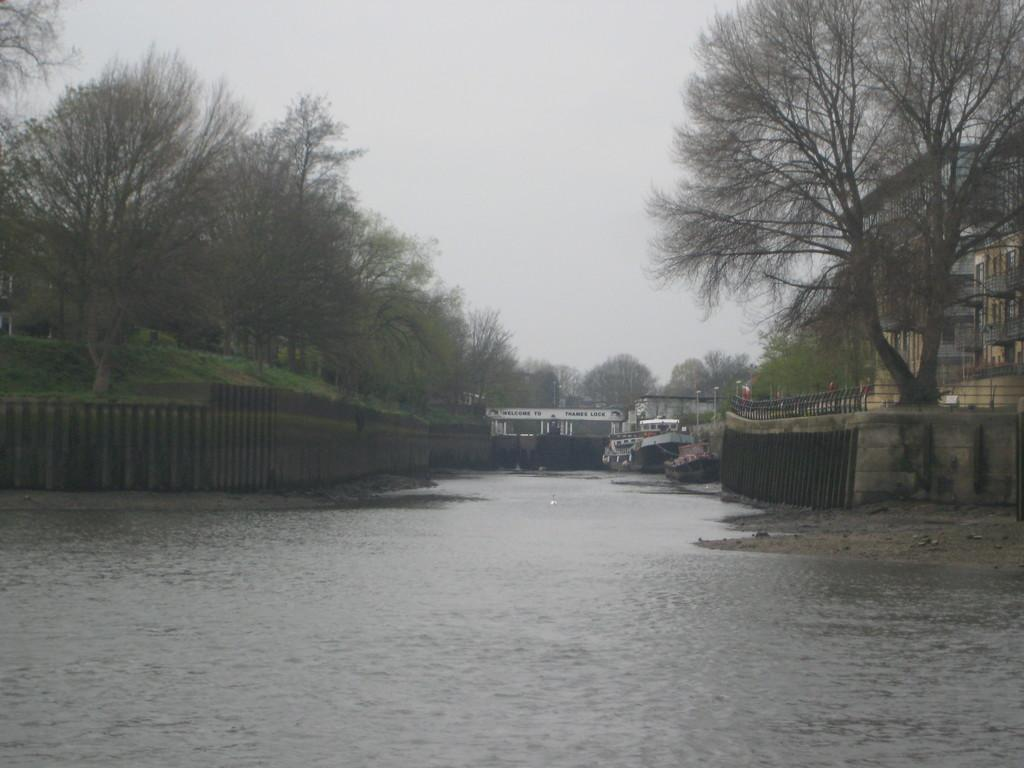What is the main element in the image? There is water in the image. What is floating on the water? There are boats in the water. What can be seen on both sides of the image? There is fencing on both sides of the image. What type of vegetation is visible in the image? There are trees visible in the image. What type of structures can be seen in the image? There are buildings in the image. What architectural feature is present in the buildings? There are windows in the image. What other objects can be seen in the image? There are poles in the image. What is the color of the sky in the image? The sky appears to be white in color. How many friends are sitting on the cork in the image? There is no cork or friends present in the image. 